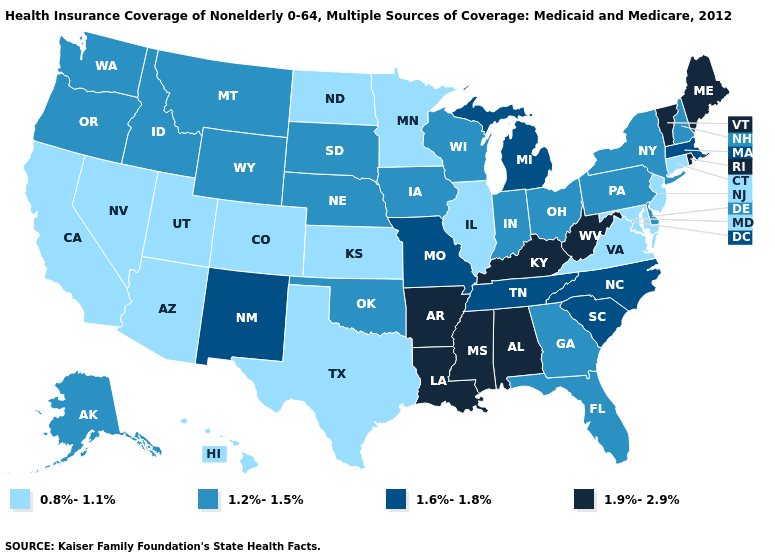Name the states that have a value in the range 1.6%-1.8%?
Keep it brief. Massachusetts, Michigan, Missouri, New Mexico, North Carolina, South Carolina, Tennessee. Does the map have missing data?
Keep it brief. No. Does Georgia have the highest value in the South?
Concise answer only. No. What is the value of Florida?
Short answer required. 1.2%-1.5%. Among the states that border Kentucky , does Virginia have the lowest value?
Short answer required. Yes. Is the legend a continuous bar?
Answer briefly. No. What is the highest value in states that border Minnesota?
Answer briefly. 1.2%-1.5%. Name the states that have a value in the range 1.2%-1.5%?
Quick response, please. Alaska, Delaware, Florida, Georgia, Idaho, Indiana, Iowa, Montana, Nebraska, New Hampshire, New York, Ohio, Oklahoma, Oregon, Pennsylvania, South Dakota, Washington, Wisconsin, Wyoming. Which states have the highest value in the USA?
Concise answer only. Alabama, Arkansas, Kentucky, Louisiana, Maine, Mississippi, Rhode Island, Vermont, West Virginia. What is the lowest value in the USA?
Answer briefly. 0.8%-1.1%. What is the highest value in states that border New Mexico?
Concise answer only. 1.2%-1.5%. Name the states that have a value in the range 1.6%-1.8%?
Keep it brief. Massachusetts, Michigan, Missouri, New Mexico, North Carolina, South Carolina, Tennessee. Does Minnesota have a higher value than Texas?
Quick response, please. No. Does Hawaii have the highest value in the West?
Short answer required. No. Does Connecticut have the lowest value in the Northeast?
Write a very short answer. Yes. 